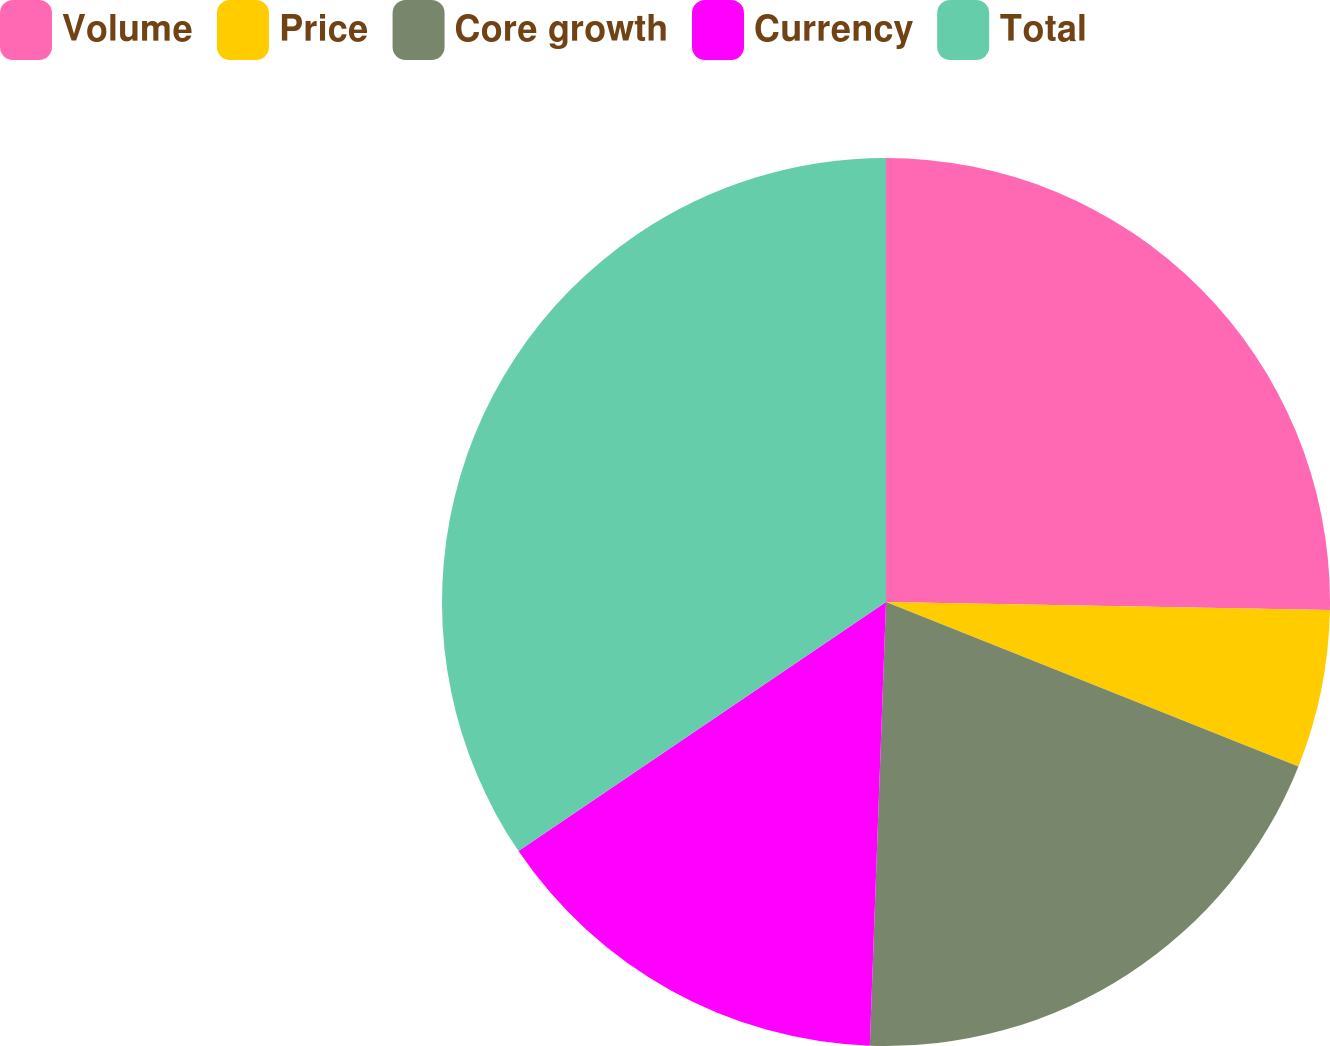Convert chart to OTSL. <chart><loc_0><loc_0><loc_500><loc_500><pie_chart><fcel>Volume<fcel>Price<fcel>Core growth<fcel>Currency<fcel>Total<nl><fcel>25.29%<fcel>5.75%<fcel>19.54%<fcel>14.94%<fcel>34.48%<nl></chart> 